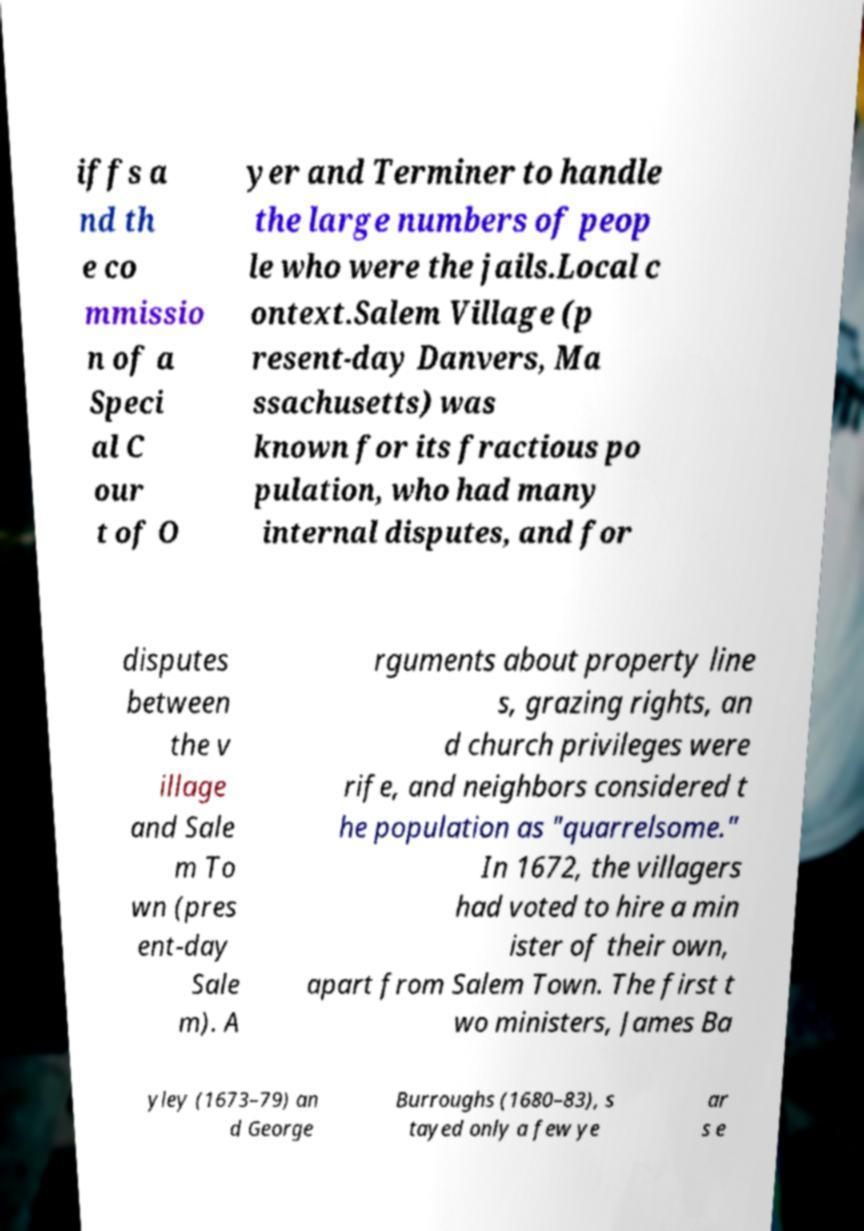What messages or text are displayed in this image? I need them in a readable, typed format. iffs a nd th e co mmissio n of a Speci al C our t of O yer and Terminer to handle the large numbers of peop le who were the jails.Local c ontext.Salem Village (p resent-day Danvers, Ma ssachusetts) was known for its fractious po pulation, who had many internal disputes, and for disputes between the v illage and Sale m To wn (pres ent-day Sale m). A rguments about property line s, grazing rights, an d church privileges were rife, and neighbors considered t he population as "quarrelsome." In 1672, the villagers had voted to hire a min ister of their own, apart from Salem Town. The first t wo ministers, James Ba yley (1673–79) an d George Burroughs (1680–83), s tayed only a few ye ar s e 